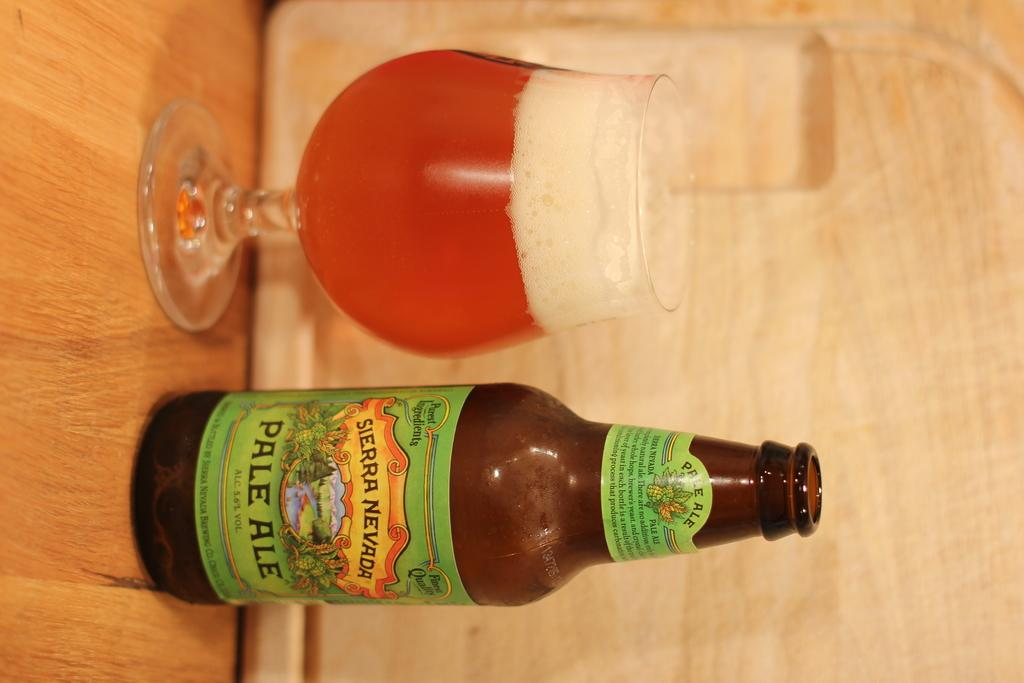<image>
Share a concise interpretation of the image provided. Brown beer bottle with a label saying "Sierra Nevada" next to a cup of beer. 